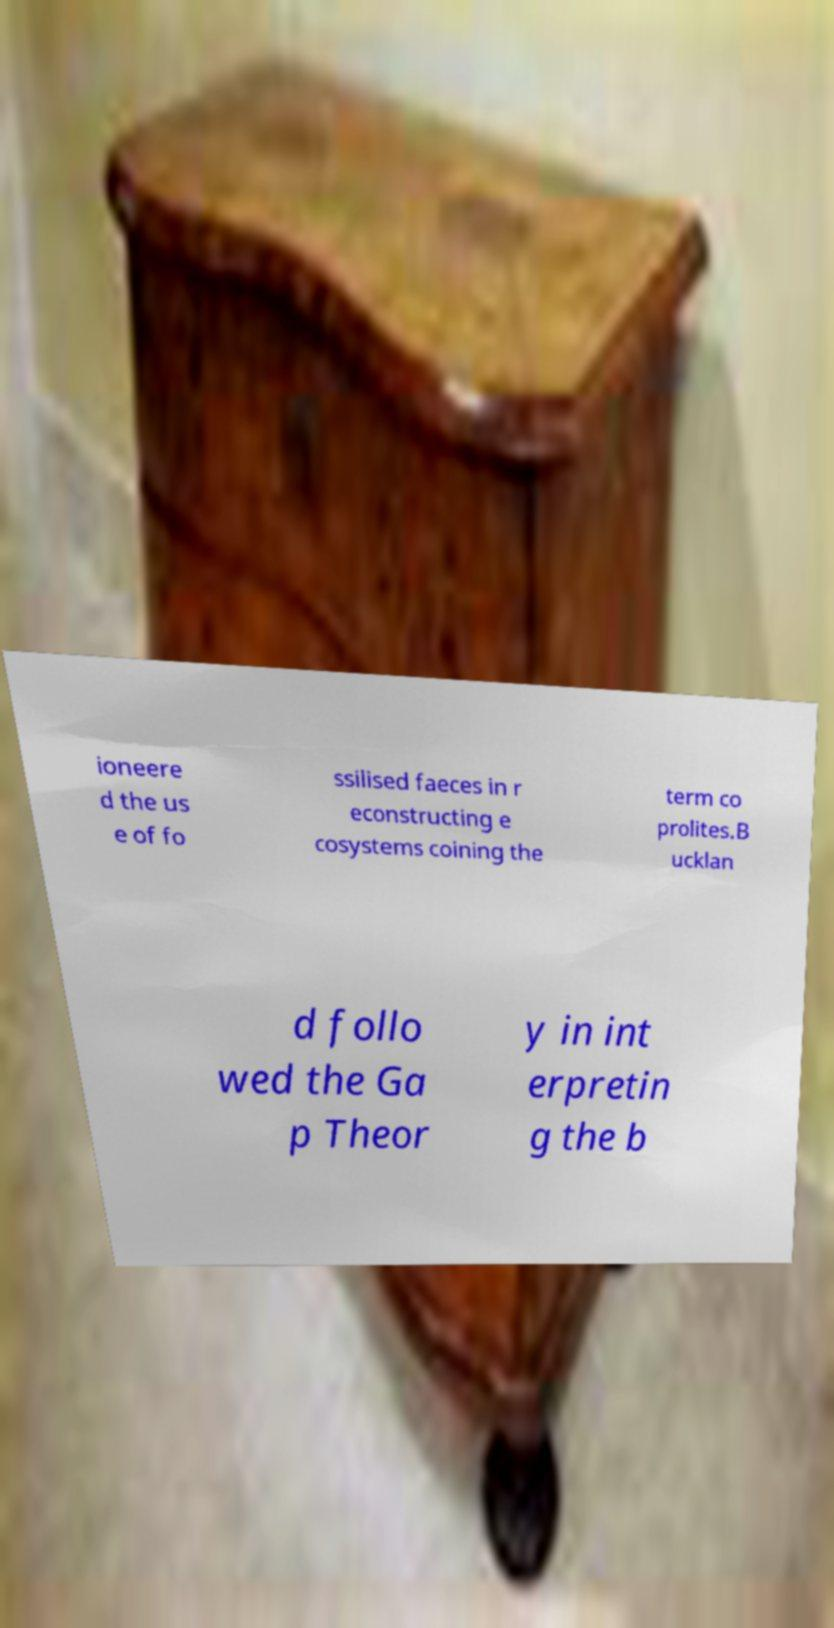For documentation purposes, I need the text within this image transcribed. Could you provide that? ioneere d the us e of fo ssilised faeces in r econstructing e cosystems coining the term co prolites.B ucklan d follo wed the Ga p Theor y in int erpretin g the b 